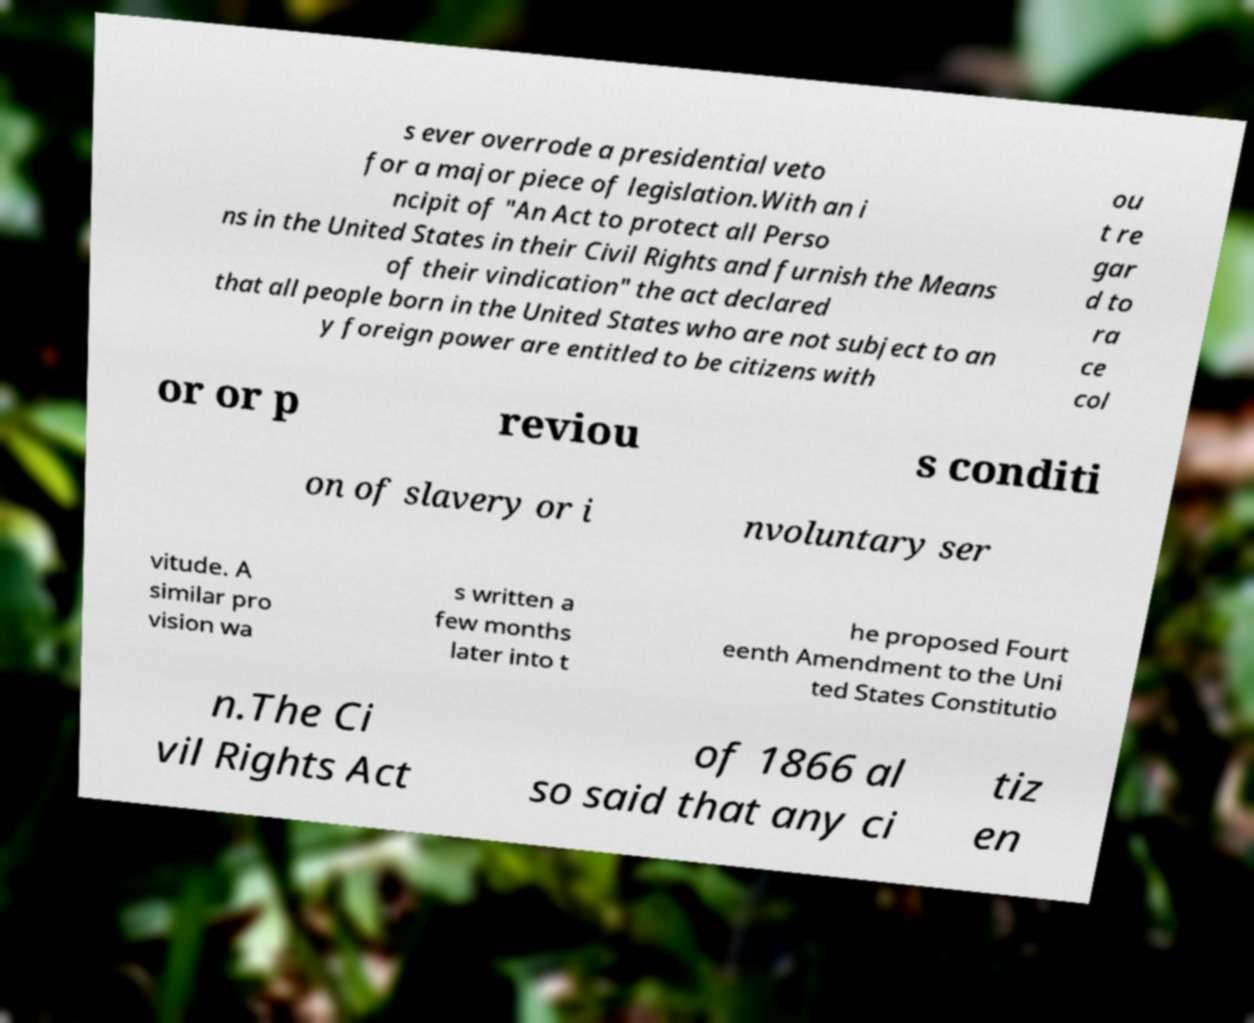Please read and relay the text visible in this image. What does it say? s ever overrode a presidential veto for a major piece of legislation.With an i ncipit of "An Act to protect all Perso ns in the United States in their Civil Rights and furnish the Means of their vindication" the act declared that all people born in the United States who are not subject to an y foreign power are entitled to be citizens with ou t re gar d to ra ce col or or p reviou s conditi on of slavery or i nvoluntary ser vitude. A similar pro vision wa s written a few months later into t he proposed Fourt eenth Amendment to the Uni ted States Constitutio n.The Ci vil Rights Act of 1866 al so said that any ci tiz en 